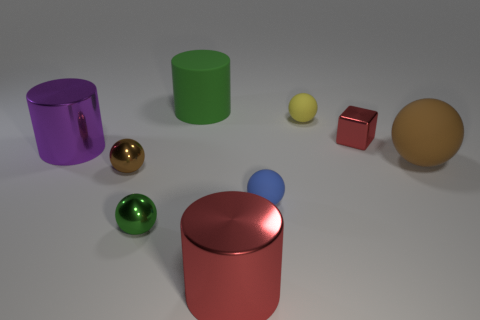Subtract all yellow balls. How many balls are left? 4 Subtract all shiny cylinders. How many cylinders are left? 1 Subtract all cubes. How many objects are left? 8 Subtract 3 balls. How many balls are left? 2 Subtract all cyan cylinders. Subtract all cyan blocks. How many cylinders are left? 3 Subtract all green blocks. How many brown balls are left? 2 Subtract all purple metallic objects. Subtract all cubes. How many objects are left? 7 Add 5 green balls. How many green balls are left? 6 Add 8 purple metallic objects. How many purple metallic objects exist? 9 Add 1 big matte things. How many objects exist? 10 